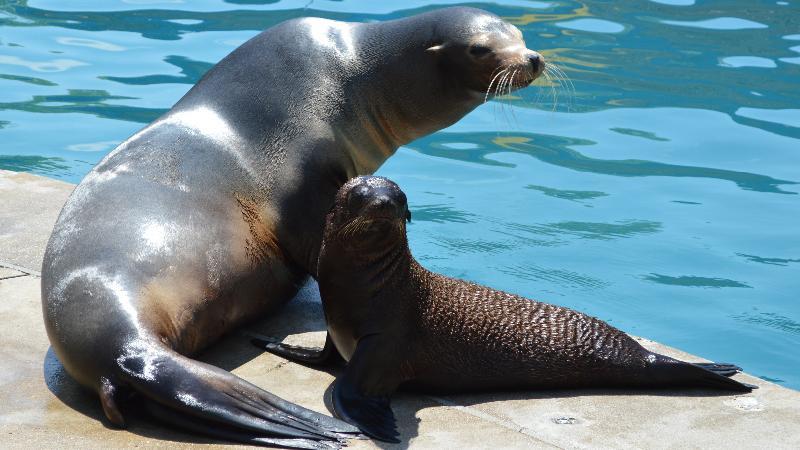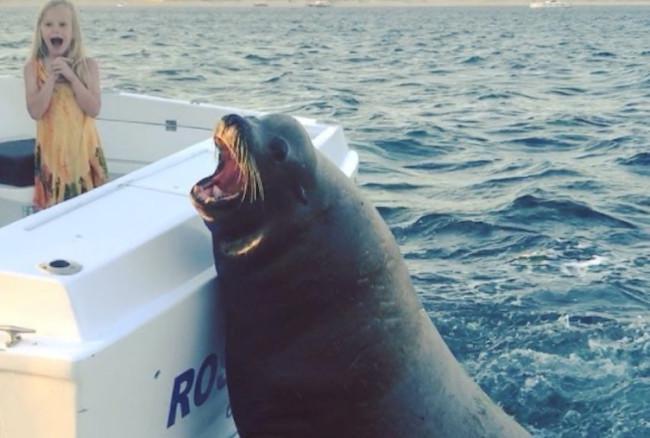The first image is the image on the left, the second image is the image on the right. Examine the images to the left and right. Is the description "The right image contains exactly two seals." accurate? Answer yes or no. No. 